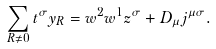Convert formula to latex. <formula><loc_0><loc_0><loc_500><loc_500>\sum _ { R \neq 0 } t ^ { \sigma } y _ { R } = w ^ { 2 } w ^ { 1 } z ^ { \sigma } + D _ { \mu } j ^ { \mu \sigma } .</formula> 